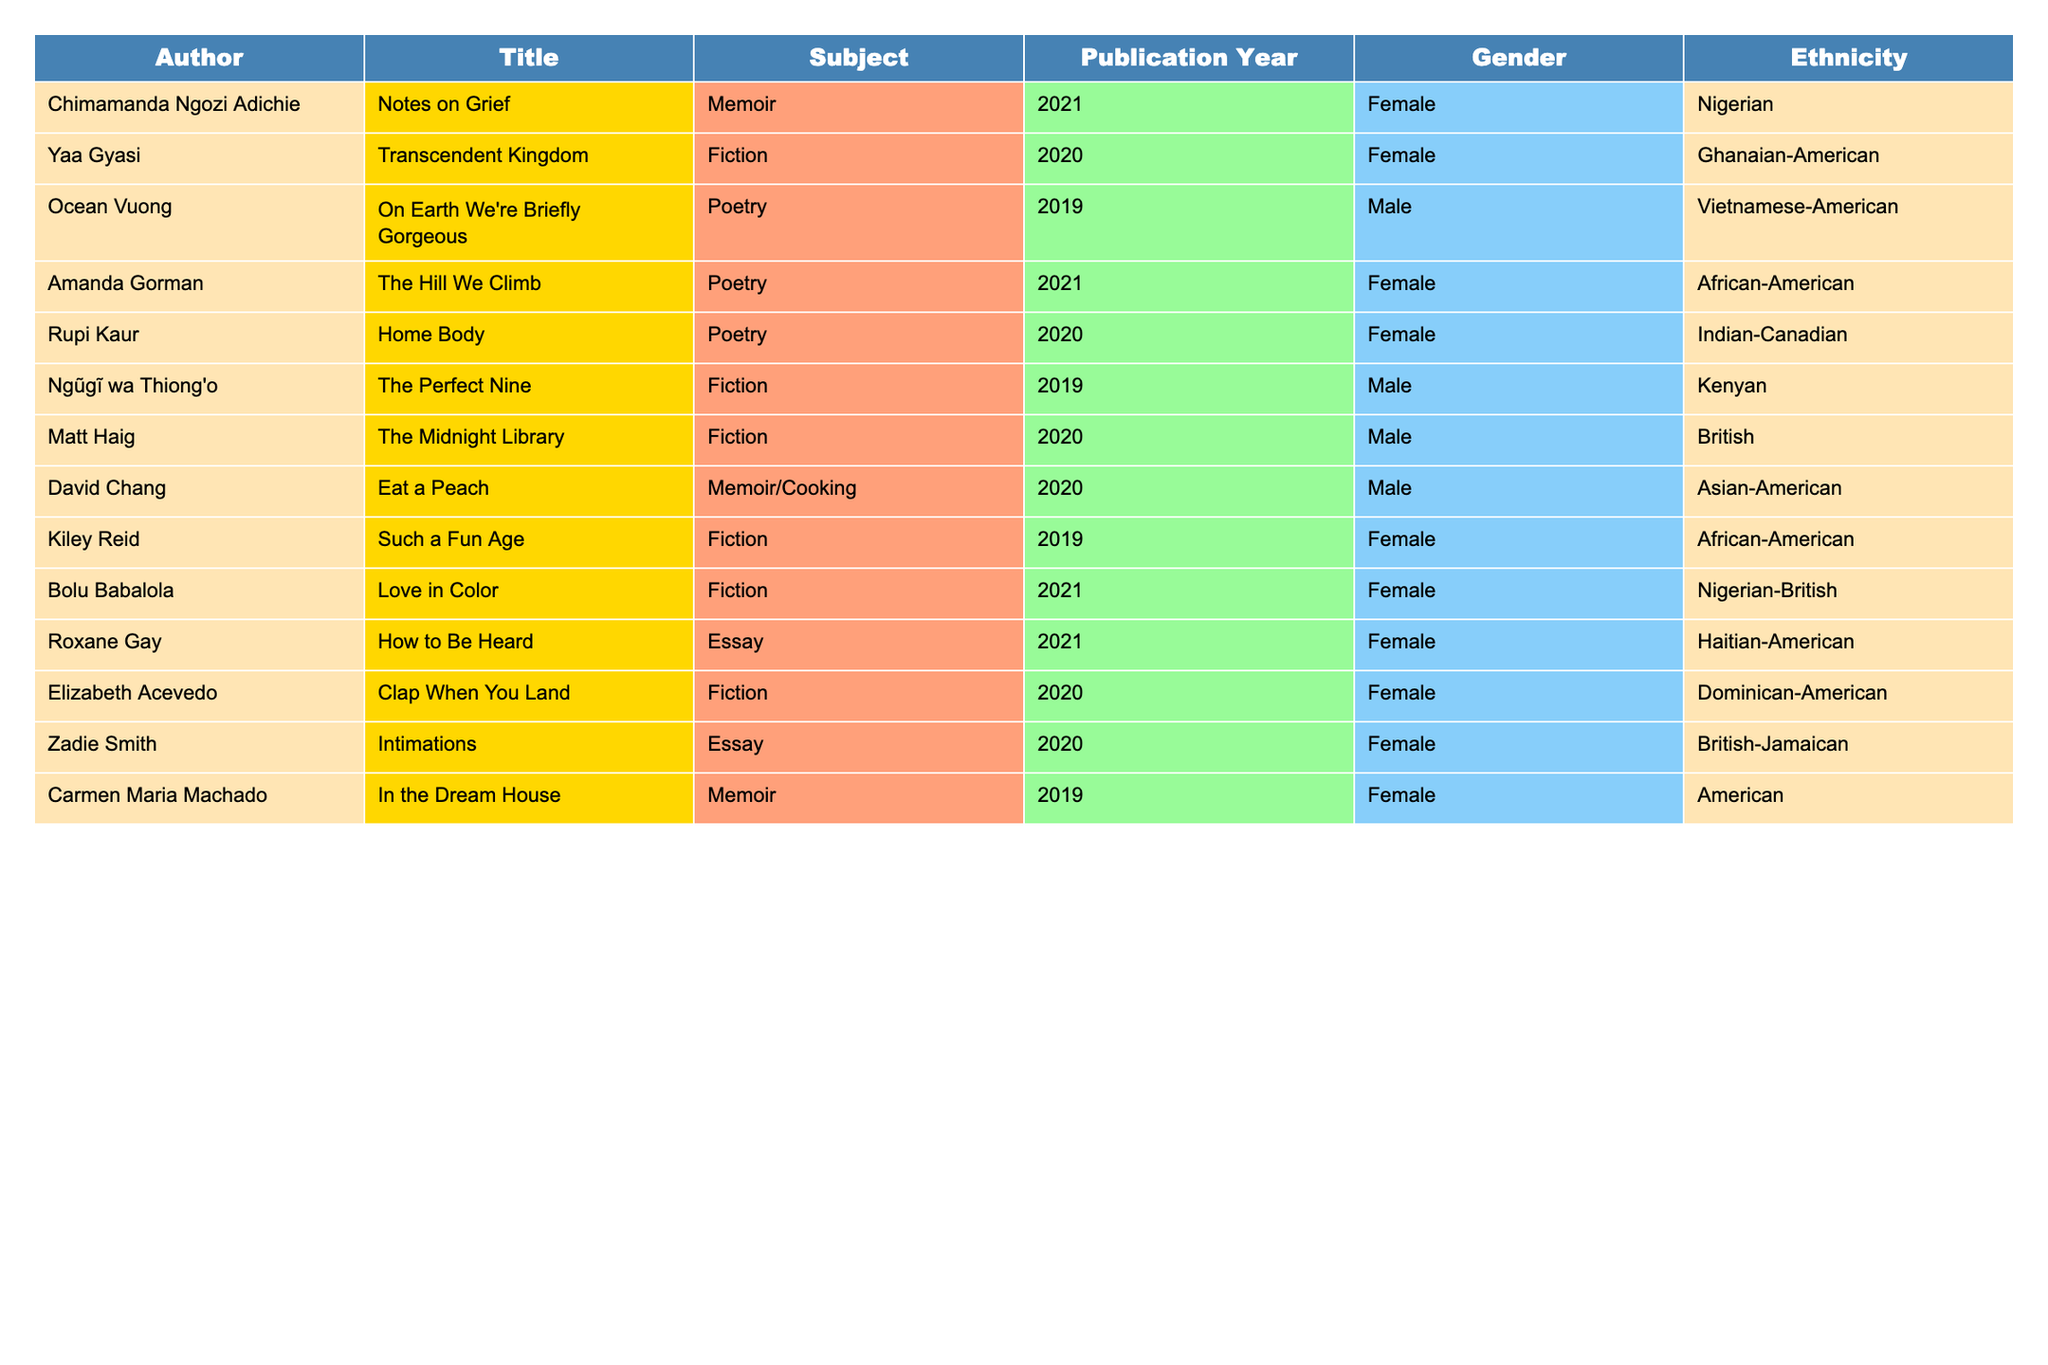What is the most common subject among the newly acquired books? The table lists various subjects and counts their occurrences. Fiction appears six times, which is more than any other subject.
Answer: Fiction How many authors in the table identify as female? By checking the gender column, there are 8 entries labeled as female: Chimamanda Ngozi Adichie, Yaa Gyasi, Amanda Gorman, Rupi Kaur, Kiley Reid, Bolu Babalola, Roxane Gay, Elizabeth Acevedo, and Zadie Smith.
Answer: 8 Which author is of Nigerian descent? The ethnicity column shows two authors from Nigeria: Chimamanda Ngozi Adichie and Bolu Babalola.
Answer: Chimamanda Ngozi Adichie and Bolu Babalola How many total different subjects are represented in the table? The subjects listed in the table are Memoir, Fiction, Poetry, Essay, and Memoir/Cooking. Counting these gives a total of 5 distinct subjects.
Answer: 5 Is there any author of Vietnamese descent in the table? Checking the ethnicity column, Ocean Vuong is identified as Vietnamese-American, confirming the presence of an author of Vietnamese descent.
Answer: Yes What percentage of the authors are male? There are 6 male authors out of a total of 14 authors. Calculating the percentage gives (6/14) * 100 = 42.86%, which can be rounded to approximately 43%.
Answer: 43% Which subject has the highest representation of authors? "Fiction" has the highest count with six authors (Yaa Gyasi, Ngũgĩ wa Thiong'o, Matt Haig, Kiley Reid, Bolu Babalola, and Elizabeth Acevedo).
Answer: Fiction How many authors published their works in the year 2021? From scanning through the publication years, there are 4 books published in 2021: Amanda Gorman, Bolu Babalola, Roxane Gay, and Zadie Smith.
Answer: 4 Is there any author who has published more than one work in the table? Checking the titles, each author has published only one work listed in the table, indicating no author is represented more than once.
Answer: No What is the ethnicity of the author who wrote "How to Be Heard"? Looking at the table, Roxane Gay, who wrote "How to Be Heard," is identified as Haitian-American.
Answer: Haitian-American How many authors are from countries in Africa? The authors from Africa listed are Chimamanda Ngozi Adichie (Nigeria), Yaa Gyasi (Ghana), Ngũgĩ wa Thiong'o (Kenya), and Kiley Reid (African-American). This accounts for 3 authors explicitly from African countries.
Answer: 3 